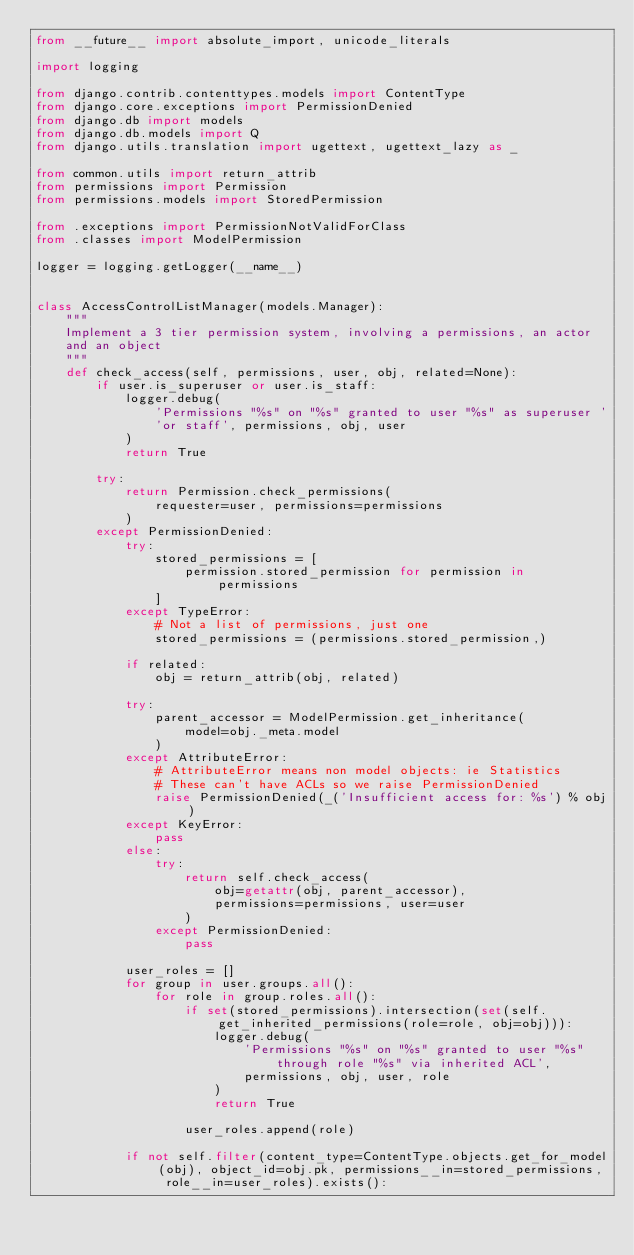Convert code to text. <code><loc_0><loc_0><loc_500><loc_500><_Python_>from __future__ import absolute_import, unicode_literals

import logging

from django.contrib.contenttypes.models import ContentType
from django.core.exceptions import PermissionDenied
from django.db import models
from django.db.models import Q
from django.utils.translation import ugettext, ugettext_lazy as _

from common.utils import return_attrib
from permissions import Permission
from permissions.models import StoredPermission

from .exceptions import PermissionNotValidForClass
from .classes import ModelPermission

logger = logging.getLogger(__name__)


class AccessControlListManager(models.Manager):
    """
    Implement a 3 tier permission system, involving a permissions, an actor
    and an object
    """
    def check_access(self, permissions, user, obj, related=None):
        if user.is_superuser or user.is_staff:
            logger.debug(
                'Permissions "%s" on "%s" granted to user "%s" as superuser '
                'or staff', permissions, obj, user
            )
            return True

        try:
            return Permission.check_permissions(
                requester=user, permissions=permissions
            )
        except PermissionDenied:
            try:
                stored_permissions = [
                    permission.stored_permission for permission in permissions
                ]
            except TypeError:
                # Not a list of permissions, just one
                stored_permissions = (permissions.stored_permission,)

            if related:
                obj = return_attrib(obj, related)

            try:
                parent_accessor = ModelPermission.get_inheritance(
                    model=obj._meta.model
                )
            except AttributeError:
                # AttributeError means non model objects: ie Statistics
                # These can't have ACLs so we raise PermissionDenied
                raise PermissionDenied(_('Insufficient access for: %s') % obj)
            except KeyError:
                pass
            else:
                try:
                    return self.check_access(
                        obj=getattr(obj, parent_accessor),
                        permissions=permissions, user=user
                    )
                except PermissionDenied:
                    pass

            user_roles = []
            for group in user.groups.all():
                for role in group.roles.all():
                    if set(stored_permissions).intersection(set(self.get_inherited_permissions(role=role, obj=obj))):
                        logger.debug(
                            'Permissions "%s" on "%s" granted to user "%s" through role "%s" via inherited ACL',
                            permissions, obj, user, role
                        )
                        return True

                    user_roles.append(role)

            if not self.filter(content_type=ContentType.objects.get_for_model(obj), object_id=obj.pk, permissions__in=stored_permissions, role__in=user_roles).exists():</code> 